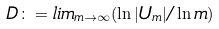Convert formula to latex. <formula><loc_0><loc_0><loc_500><loc_500>D \colon = l i m _ { m \to \infty } ( \ln | U _ { m } | / \ln m )</formula> 